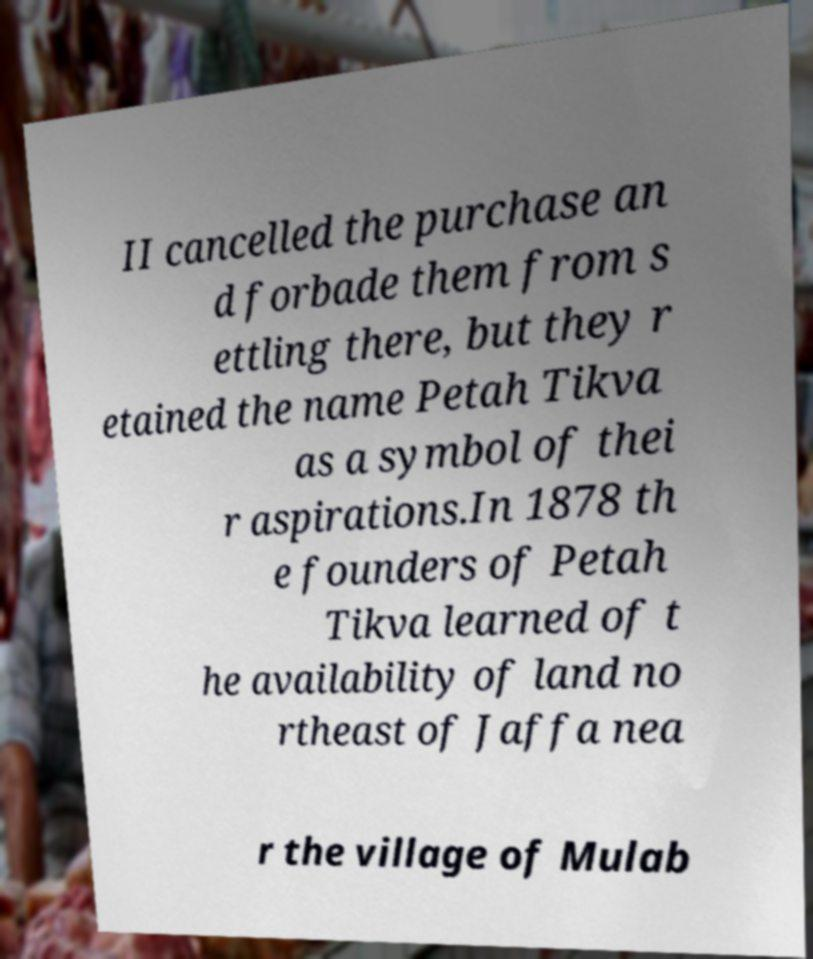Could you assist in decoding the text presented in this image and type it out clearly? II cancelled the purchase an d forbade them from s ettling there, but they r etained the name Petah Tikva as a symbol of thei r aspirations.In 1878 th e founders of Petah Tikva learned of t he availability of land no rtheast of Jaffa nea r the village of Mulab 